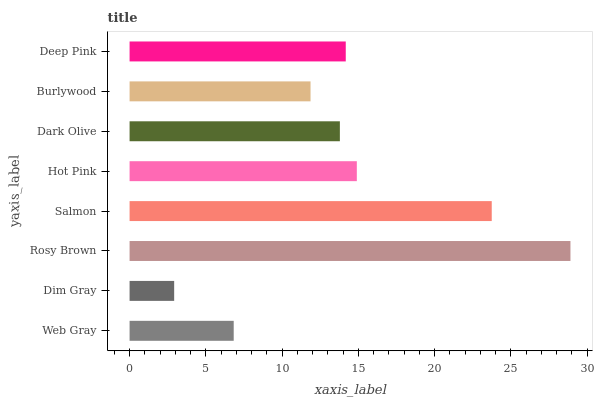Is Dim Gray the minimum?
Answer yes or no. Yes. Is Rosy Brown the maximum?
Answer yes or no. Yes. Is Rosy Brown the minimum?
Answer yes or no. No. Is Dim Gray the maximum?
Answer yes or no. No. Is Rosy Brown greater than Dim Gray?
Answer yes or no. Yes. Is Dim Gray less than Rosy Brown?
Answer yes or no. Yes. Is Dim Gray greater than Rosy Brown?
Answer yes or no. No. Is Rosy Brown less than Dim Gray?
Answer yes or no. No. Is Deep Pink the high median?
Answer yes or no. Yes. Is Dark Olive the low median?
Answer yes or no. Yes. Is Salmon the high median?
Answer yes or no. No. Is Salmon the low median?
Answer yes or no. No. 